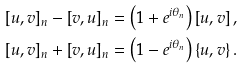<formula> <loc_0><loc_0><loc_500><loc_500>\left [ u , v \right ] _ { n } - \left [ v , u \right ] _ { n } & = \left ( 1 + e ^ { i \theta _ { n } } \right ) \left [ u , v \right ] , \\ \left [ u , v \right ] _ { n } + \left [ v , u \right ] _ { n } & = \left ( 1 - e ^ { i \theta _ { n } } \right ) \left \{ u , v \right \} .</formula> 